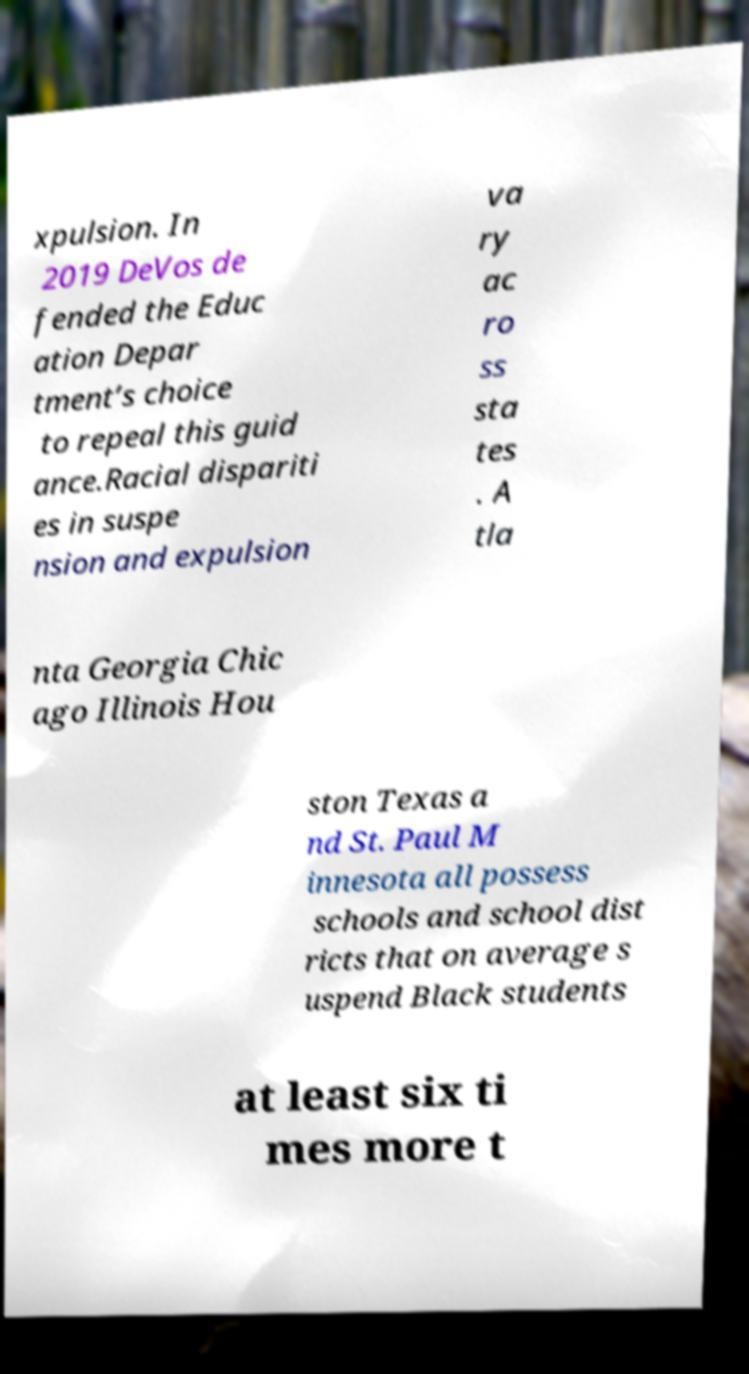Could you extract and type out the text from this image? xpulsion. In 2019 DeVos de fended the Educ ation Depar tment’s choice to repeal this guid ance.Racial dispariti es in suspe nsion and expulsion va ry ac ro ss sta tes . A tla nta Georgia Chic ago Illinois Hou ston Texas a nd St. Paul M innesota all possess schools and school dist ricts that on average s uspend Black students at least six ti mes more t 